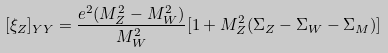Convert formula to latex. <formula><loc_0><loc_0><loc_500><loc_500>[ \xi _ { Z } ] _ { Y Y } = \frac { e ^ { 2 } ( M _ { Z } ^ { 2 } - M _ { W } ^ { 2 } ) } { M _ { W } ^ { 2 } } [ 1 + M _ { Z } ^ { 2 } ( \Sigma _ { Z } - \Sigma _ { W } - \Sigma _ { M } ) ]</formula> 